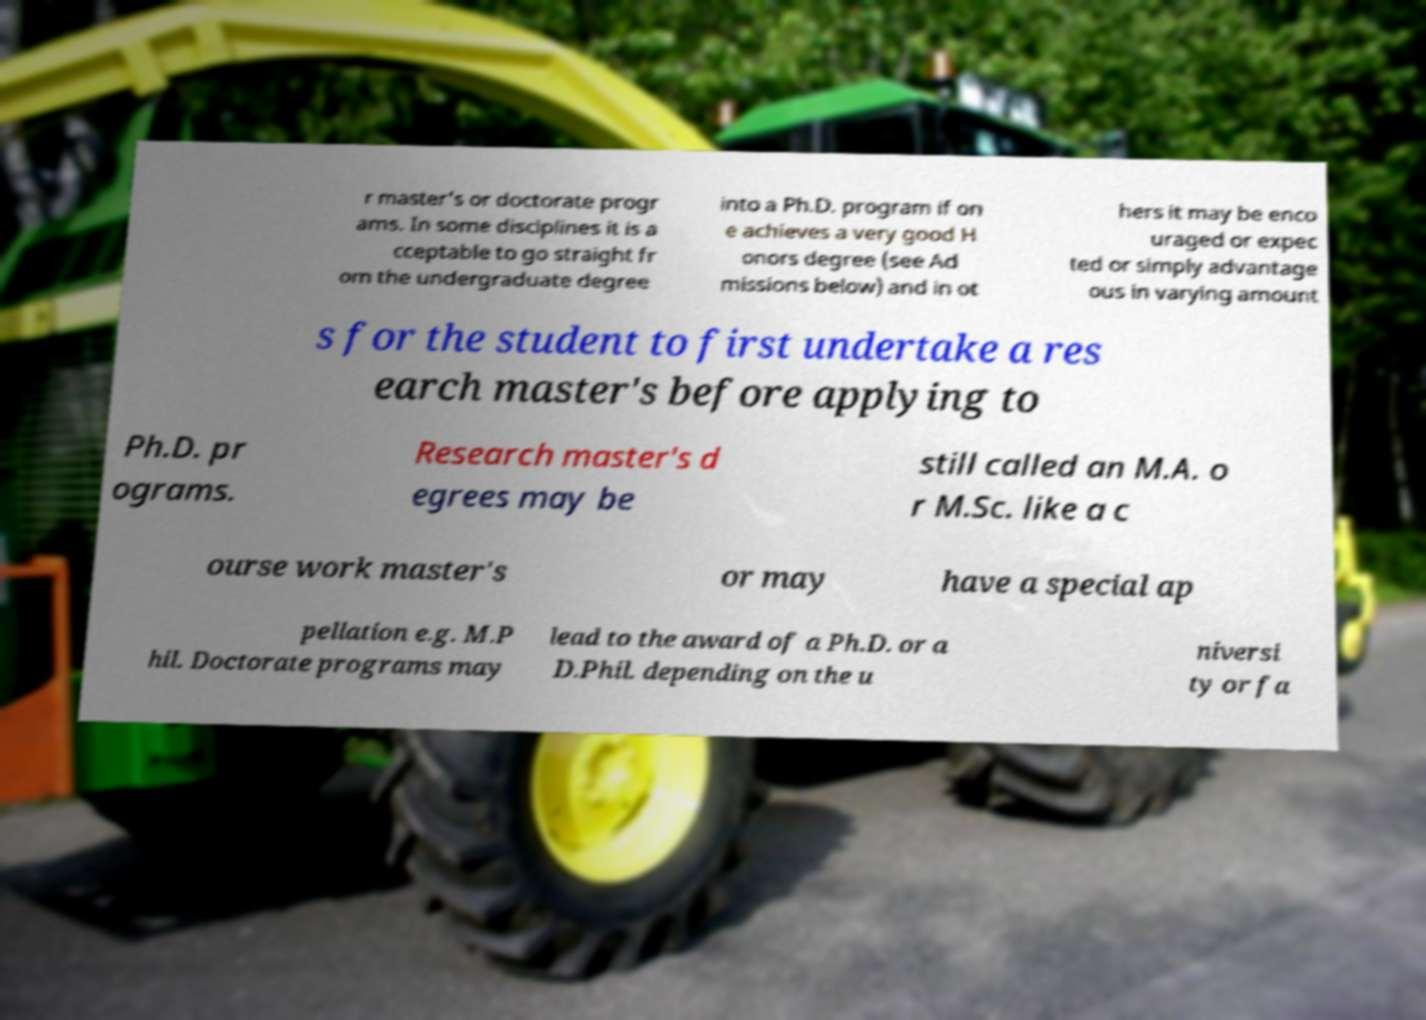Please identify and transcribe the text found in this image. r master's or doctorate progr ams. In some disciplines it is a cceptable to go straight fr om the undergraduate degree into a Ph.D. program if on e achieves a very good H onors degree (see Ad missions below) and in ot hers it may be enco uraged or expec ted or simply advantage ous in varying amount s for the student to first undertake a res earch master's before applying to Ph.D. pr ograms. Research master's d egrees may be still called an M.A. o r M.Sc. like a c ourse work master's or may have a special ap pellation e.g. M.P hil. Doctorate programs may lead to the award of a Ph.D. or a D.Phil. depending on the u niversi ty or fa 